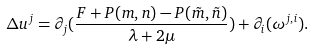Convert formula to latex. <formula><loc_0><loc_0><loc_500><loc_500>\Delta u ^ { j } = \partial _ { j } ( \frac { F + P ( m , n ) - P ( \tilde { m } , \tilde { n } ) } { \lambda + 2 \mu } ) + \partial _ { i } ( \omega ^ { j , i } ) .</formula> 